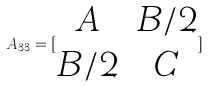Convert formula to latex. <formula><loc_0><loc_0><loc_500><loc_500>A _ { 3 3 } = [ \begin{matrix} A & B / 2 \\ B / 2 & C \end{matrix} ]</formula> 